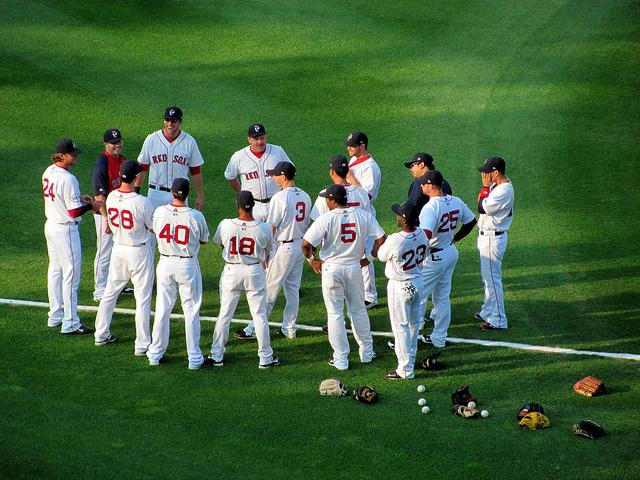Which equipment would be fastest for them to use? Please explain your reasoning. shoes. People's shoes are already on. 